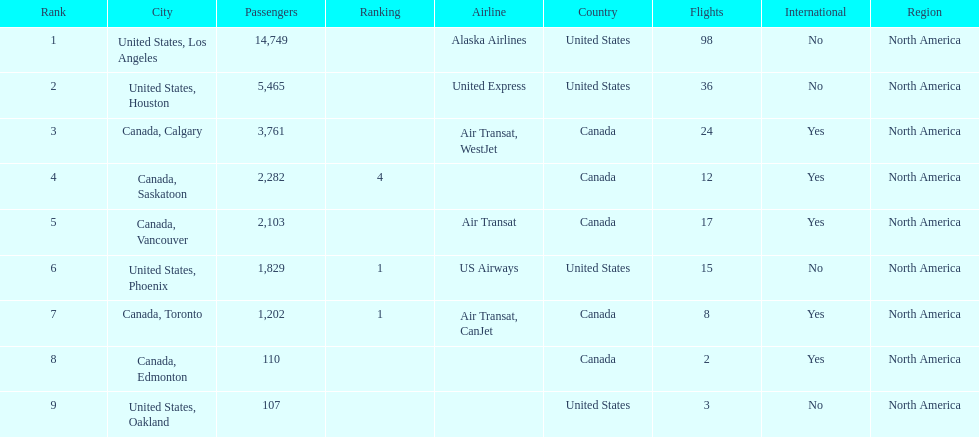What are the cities that are associated with the playa de oro international airport? United States, Los Angeles, United States, Houston, Canada, Calgary, Canada, Saskatoon, Canada, Vancouver, United States, Phoenix, Canada, Toronto, Canada, Edmonton, United States, Oakland. What is uniteed states, los angeles passenger count? 14,749. Could you parse the entire table as a dict? {'header': ['Rank', 'City', 'Passengers', 'Ranking', 'Airline', 'Country', 'Flights', 'International', 'Region'], 'rows': [['1', 'United States, Los Angeles', '14,749', '', 'Alaska Airlines', 'United States', '98', 'No', 'North America'], ['2', 'United States, Houston', '5,465', '', 'United Express', 'United States', '36', 'No', 'North America'], ['3', 'Canada, Calgary', '3,761', '', 'Air Transat, WestJet', 'Canada', '24', 'Yes', 'North America'], ['4', 'Canada, Saskatoon', '2,282', '4', '', 'Canada', '12', 'Yes', 'North America'], ['5', 'Canada, Vancouver', '2,103', '', 'Air Transat', 'Canada', '17', 'Yes', 'North America'], ['6', 'United States, Phoenix', '1,829', '1', 'US Airways', 'United States', '15', 'No', 'North America'], ['7', 'Canada, Toronto', '1,202', '1', 'Air Transat, CanJet', 'Canada', '8', 'Yes', 'North America'], ['8', 'Canada, Edmonton', '110', '', '', 'Canada', '2', 'Yes', 'North America'], ['9', 'United States, Oakland', '107', '', '', 'United States', '3', 'No', 'North America']]} What other cities passenger count would lead to 19,000 roughly when combined with previous los angeles? Canada, Calgary. 